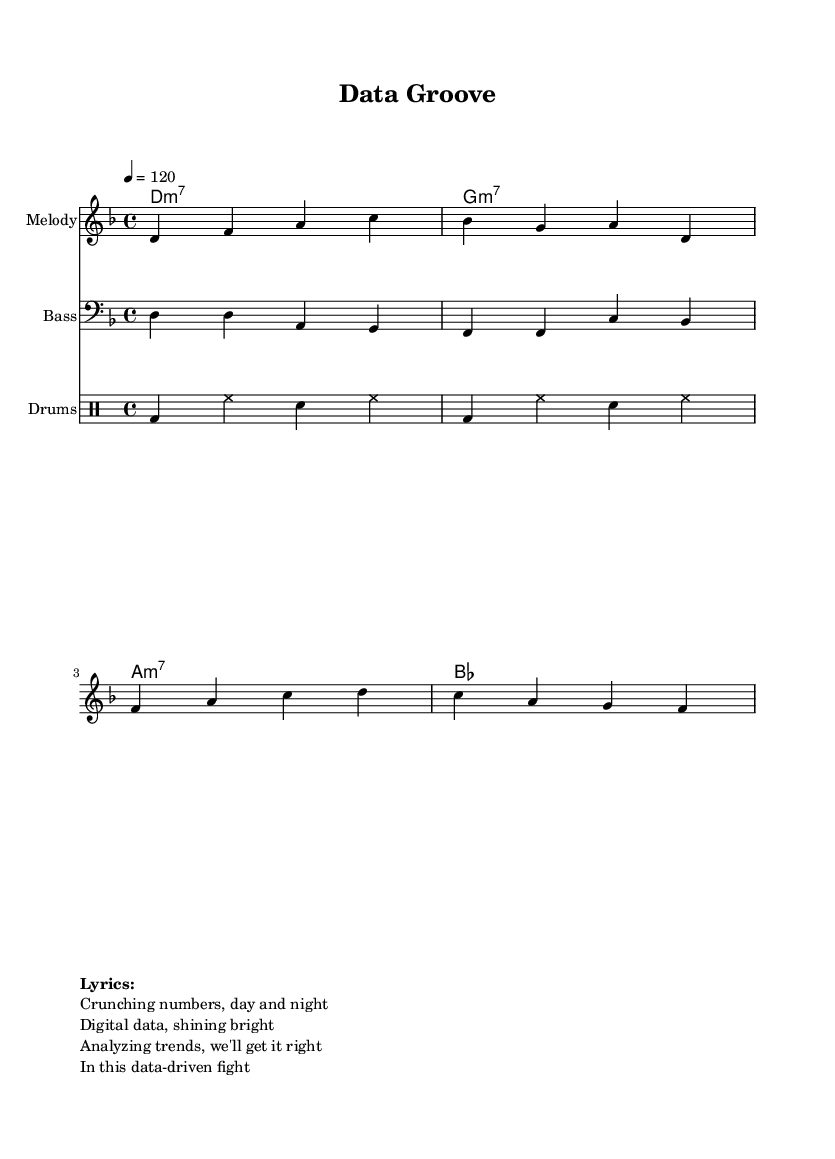What is the key signature of this music? The key signature is D minor, as indicated by one flat (B flat) in the staff.
Answer: D minor What is the time signature of this music? The time signature is 4/4, as indicated at the beginning of the score.
Answer: 4/4 What is the tempo marking for this piece? The tempo marking is quarter note equals 120. This is a common way to express how fast the piece should be played, referring to the speed of the quarter note.
Answer: 120 What type of chord is indicated in the first measure? The first chord is a D minor 7th (m7), as indicated in the chord names section of the score.
Answer: D minor 7th How many measures are in the melody section? The melody section contains 4 measures, as identified by the vertical bar lines in the score.
Answer: 4 measures What is the main rhythmic feature present in the drums part? The main rhythmic feature is the repeated use of the hi-hat on every eighth note, contributing to the funk groove. This creates a driving feel typical in funk music.
Answer: Hi-hat on eighth notes What lyrical theme is explored in this funk anthem? The lyrical theme focuses on data analysis and problem-solving, as reflected in the text which mentions crunching numbers and analyzing trends.
Answer: Data analysis 